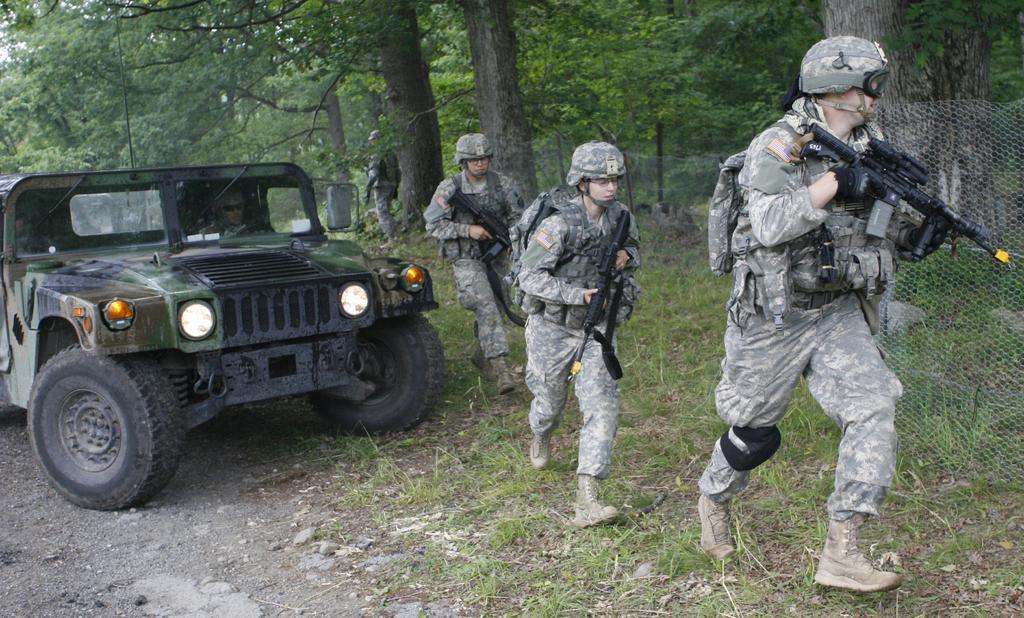Please provide a concise description of this image. In this picture we can see a vehicle on the ground with a person sitting in it, fencing net, three people are holding guns with their hands and walking on the grass. In the background we can see a person and trees. 